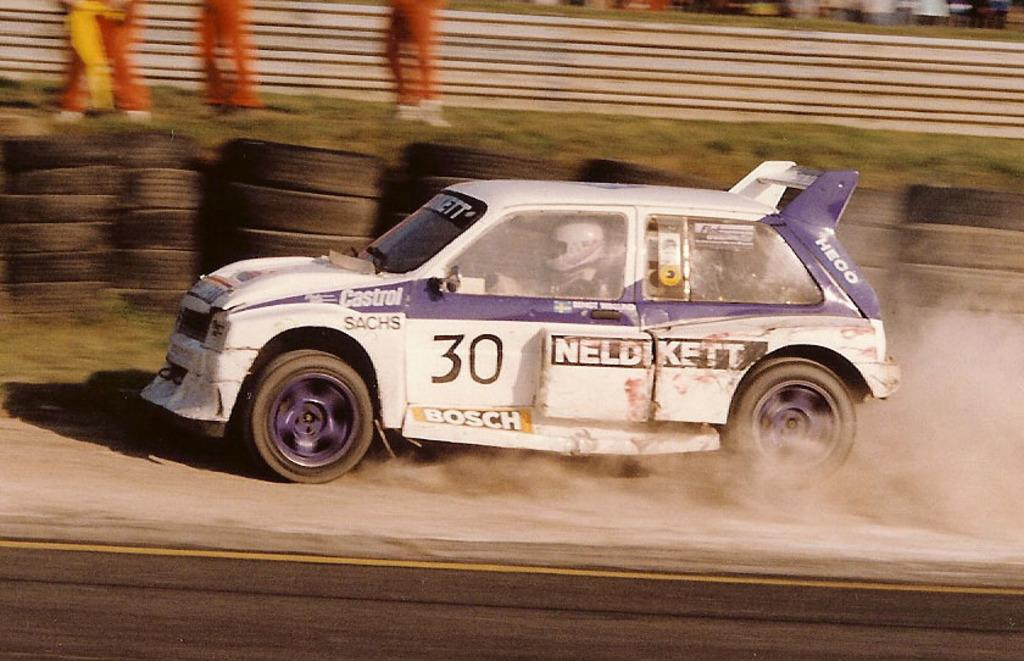What is the main subject of the image? There is a vehicle in the image. What colors are used for the vehicle? The vehicle is white and purple in color. Can you describe the person inside the vehicle? There is a person sitting inside the vehicle. What type of vegetation is visible in the background of the image? The background of the image includes grass. What is the color of the grass? The grass is green in color. How many drawers are visible in the image? There are no drawers present in the image. What type of holiday is being celebrated in the image? There is no indication of a holiday being celebrated in the image. 